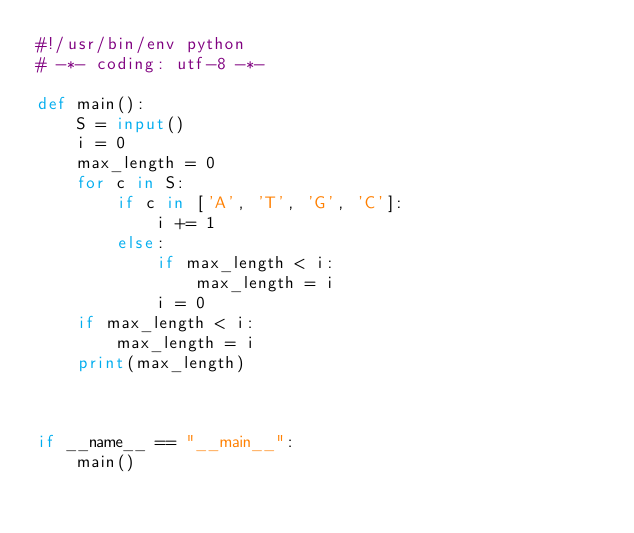Convert code to text. <code><loc_0><loc_0><loc_500><loc_500><_Python_>#!/usr/bin/env python
# -*- coding: utf-8 -*-

def main():
    S = input()
    i = 0
    max_length = 0
    for c in S:
        if c in ['A', 'T', 'G', 'C']:
            i += 1
        else:
            if max_length < i:
                max_length = i
            i = 0
    if max_length < i:
        max_length = i
    print(max_length)



if __name__ == "__main__":
    main()</code> 